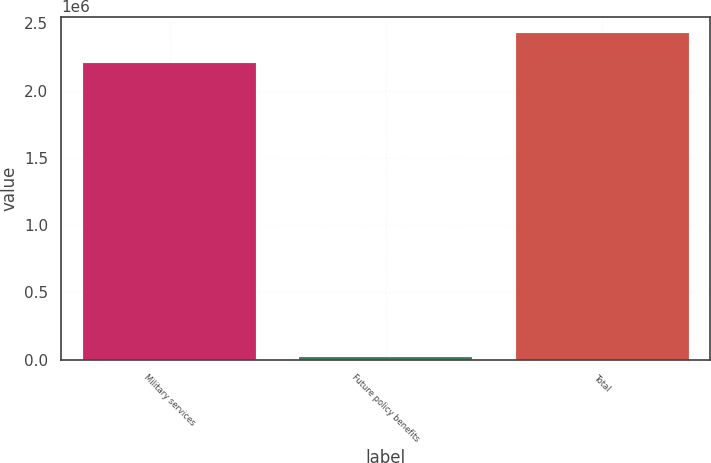Convert chart. <chart><loc_0><loc_0><loc_500><loc_500><bar_chart><fcel>Military services<fcel>Future policy benefits<fcel>Total<nl><fcel>2.20803e+06<fcel>17314<fcel>2.42884e+06<nl></chart> 